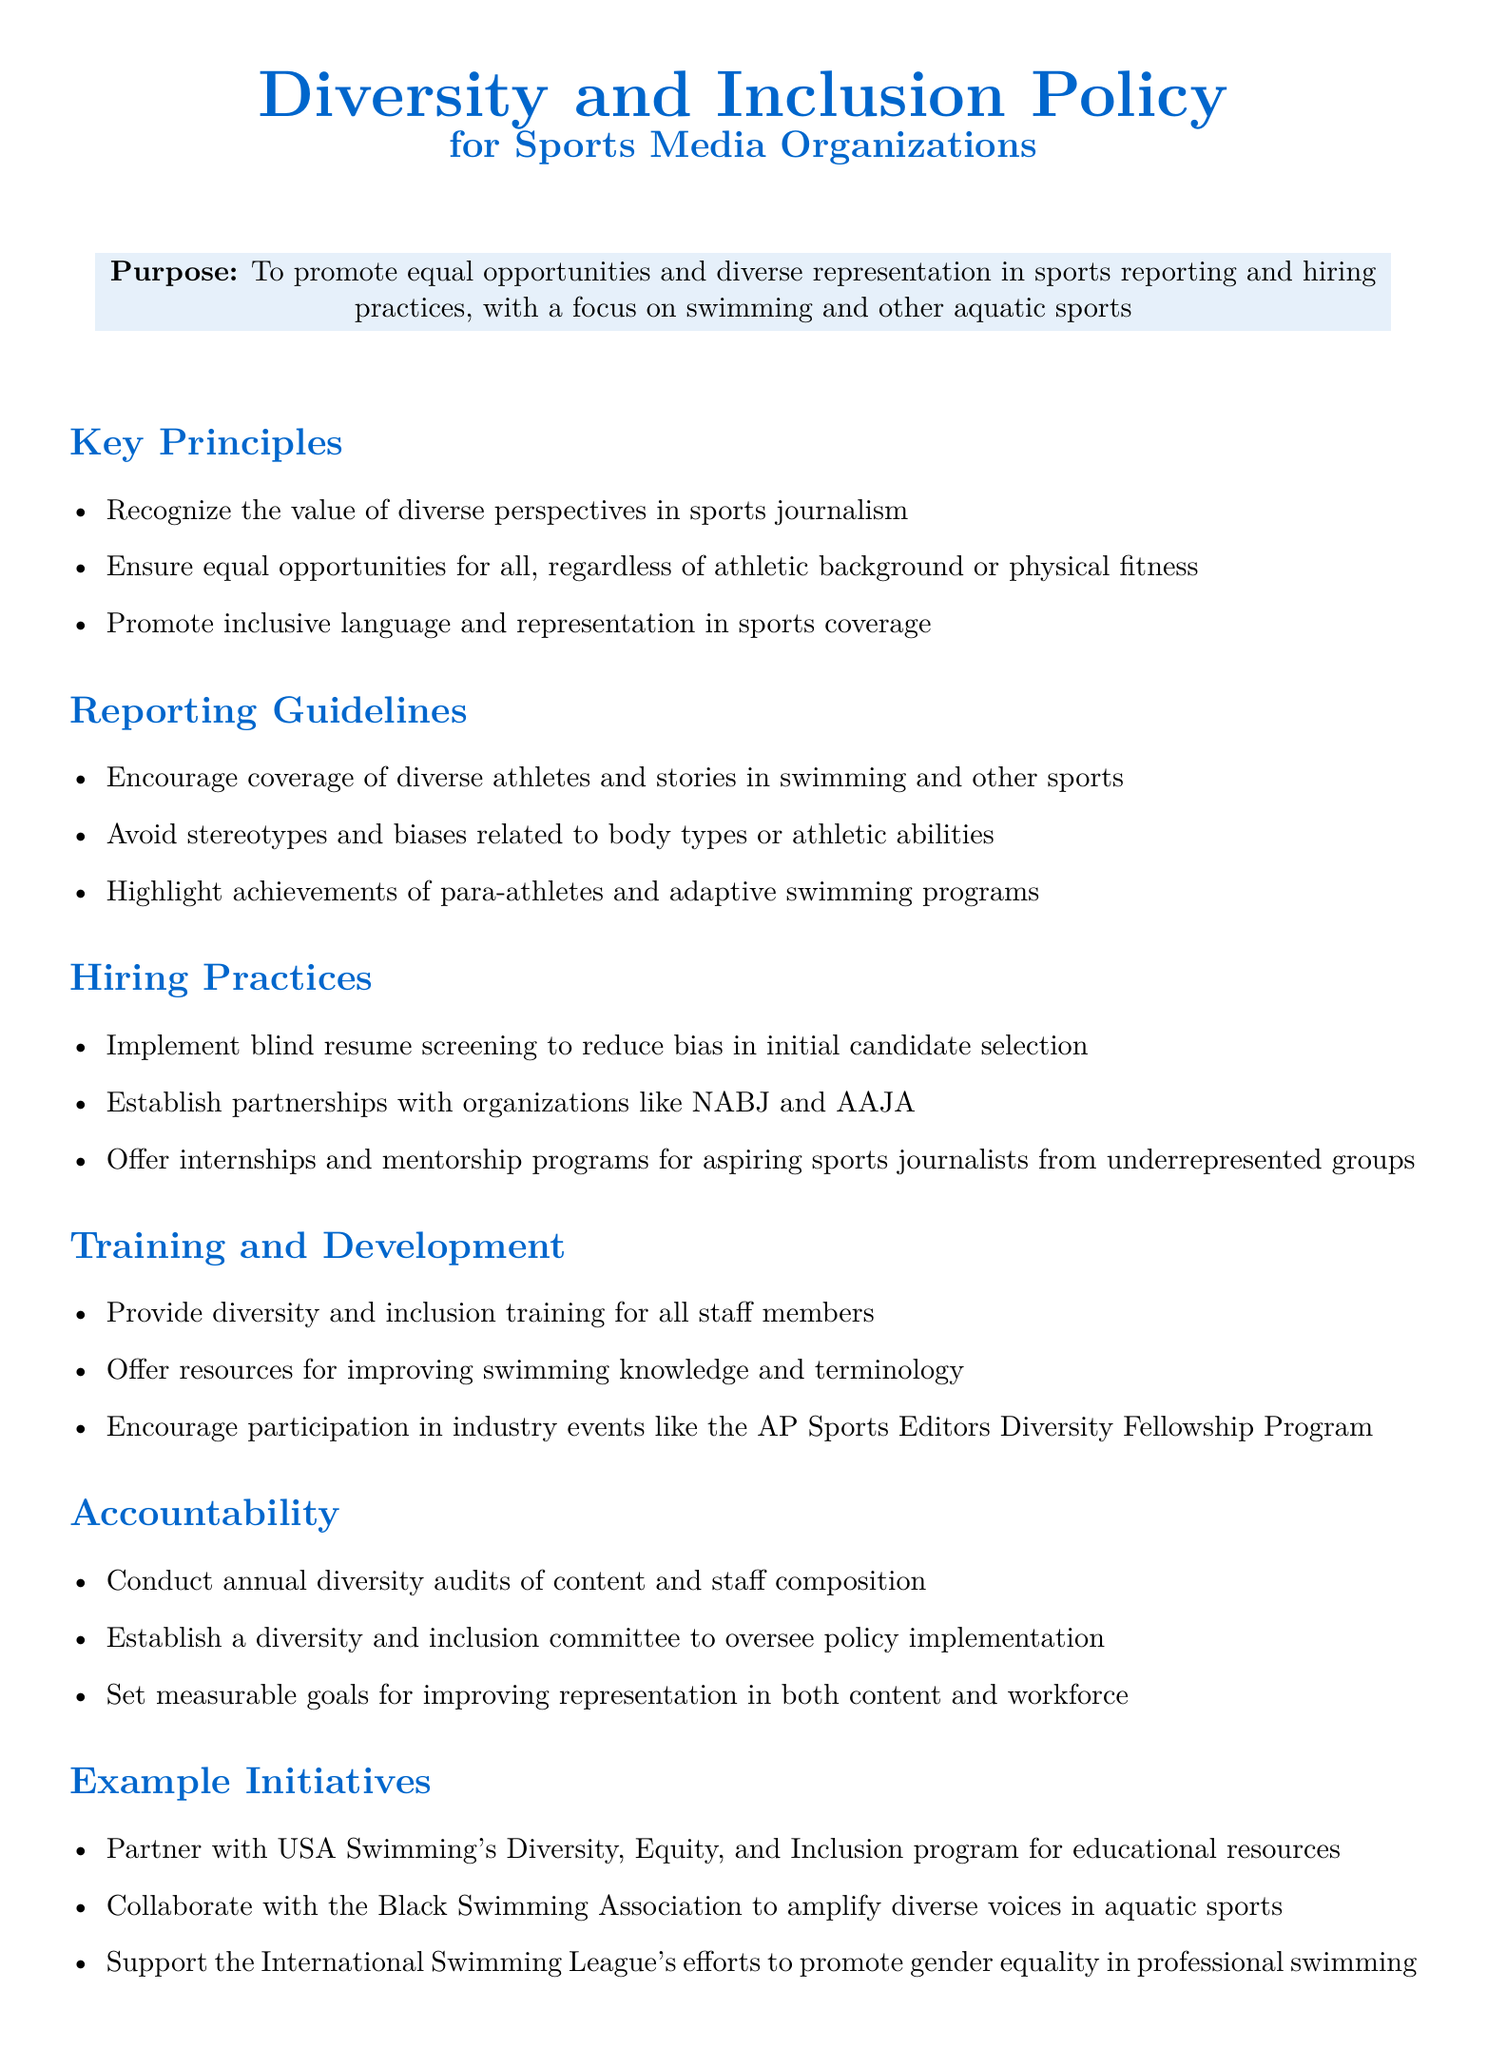What is the purpose of the policy? The purpose outlines the aim of promoting equal opportunities and diverse representation in sports reporting and hiring practices.
Answer: To promote equal opportunities and diverse representation in sports reporting and hiring practices What does the policy say about reporting guidelines? This section specifies the main points related to coverage and portrayal of athletes and stories in sports.
Answer: Encourage coverage of diverse athletes and stories in swimming and other sports What is one initiative mentioned in the document? This requires identifying a specific example of collaboration or support related to diversity and inclusion.
Answer: Partner with USA Swimming's Diversity, Equity, and Inclusion program for educational resources How many key principles are listed in the document? This involves counting the principles provided in the key principles section.
Answer: Three What bodies are mentioned as partners in hiring practices? This question requires identifying organizations that the policy aims to partner with for improving diversity in hiring.
Answer: NABJ and AAJA What type of training is provided to staff members? This question asks for the nature of the training mentioned in the training section of the document.
Answer: Diversity and inclusion training What is the role of the diversity and inclusion committee? This requires understanding the responsibilities assigned to the committee as outlined in the accountability section.
Answer: Oversee policy implementation When are diversity audits conducted? This asks for the frequency of the audits as specified in the accountability section of the document.
Answer: Annually 